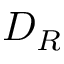<formula> <loc_0><loc_0><loc_500><loc_500>D _ { R }</formula> 